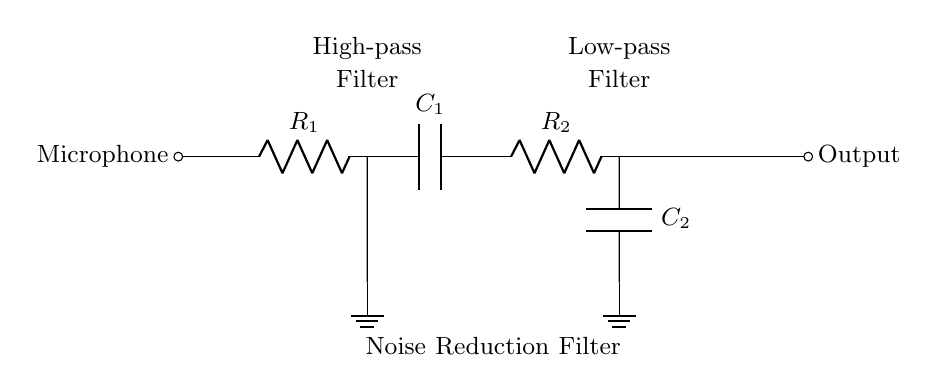What type of filter is used in this circuit? The circuit includes two types of filters: a high-pass filter and a low-pass filter. The high-pass filter is indicated by the arrangement of the resistor and capacitor at the beginning of the circuit, while the low-pass filter is at the end.
Answer: High-pass and low-pass What components are used in the high-pass filter? The high-pass filter consists of a resistor labeled R1 and a capacitor labeled C1. The arrangement of these components allows the circuit to pass high frequencies while blocking low frequencies.
Answer: Resistor and capacitor What does the low-pass filter do? The low-pass filter, made up of R2 and C2, allows low-frequency signals to pass through while attenuating high-frequency signals. This design serves to smooth out the output by reducing high-frequency noise.
Answer: Attenuates high frequencies How are the components connected in the high-pass filter? In the high-pass filter, R1 is connected in series with C1, and C1 is connected to ground. This series connection influences the frequency response of the filter.
Answer: R1 in series with C1 What is the purpose of the noise reduction filter? The noise reduction filter, which includes both the high-pass and low-pass filters, aims to improve the microphone signal quality by filtering out unwanted noise components from the audio signal.
Answer: Improve signal quality What is the output of this circuit? The output is taken from the end of the low-pass filter, indicating the final signal after noise reduction has occurred and processed through both filter types, suitable for audio usage.
Answer: Output signal 